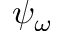Convert formula to latex. <formula><loc_0><loc_0><loc_500><loc_500>\psi _ { \omega }</formula> 